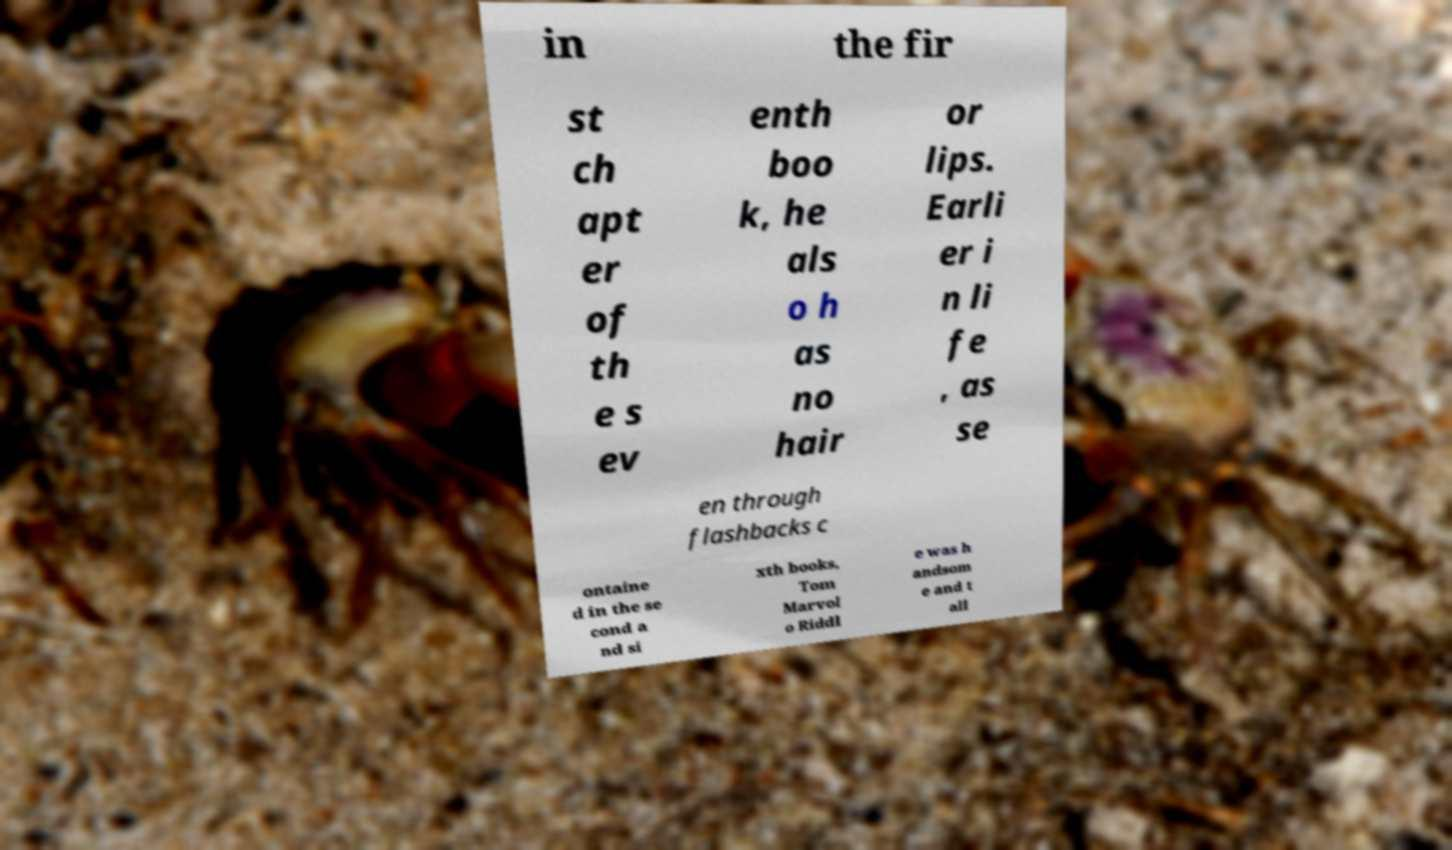For documentation purposes, I need the text within this image transcribed. Could you provide that? in the fir st ch apt er of th e s ev enth boo k, he als o h as no hair or lips. Earli er i n li fe , as se en through flashbacks c ontaine d in the se cond a nd si xth books, Tom Marvol o Riddl e was h andsom e and t all 